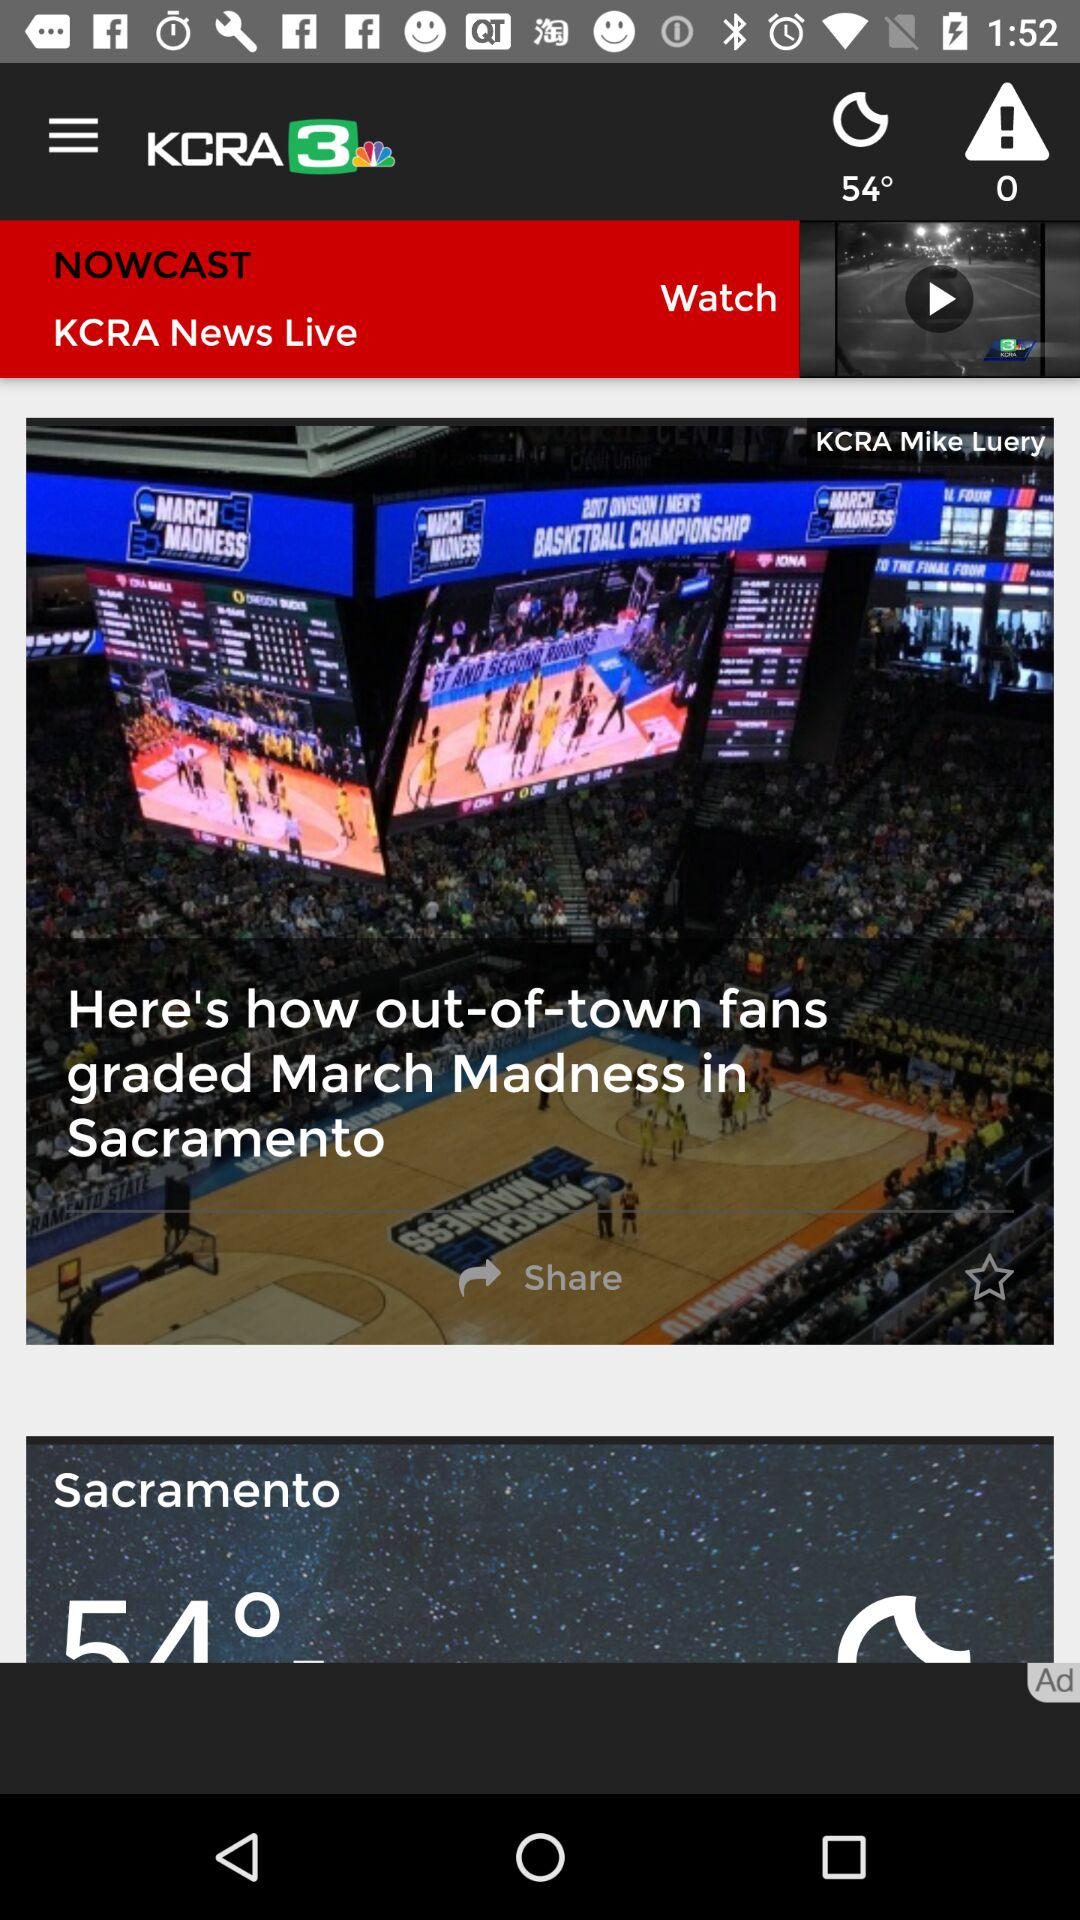On which television station is the news posted? The news is posted on the "KCRA 3" television station. 